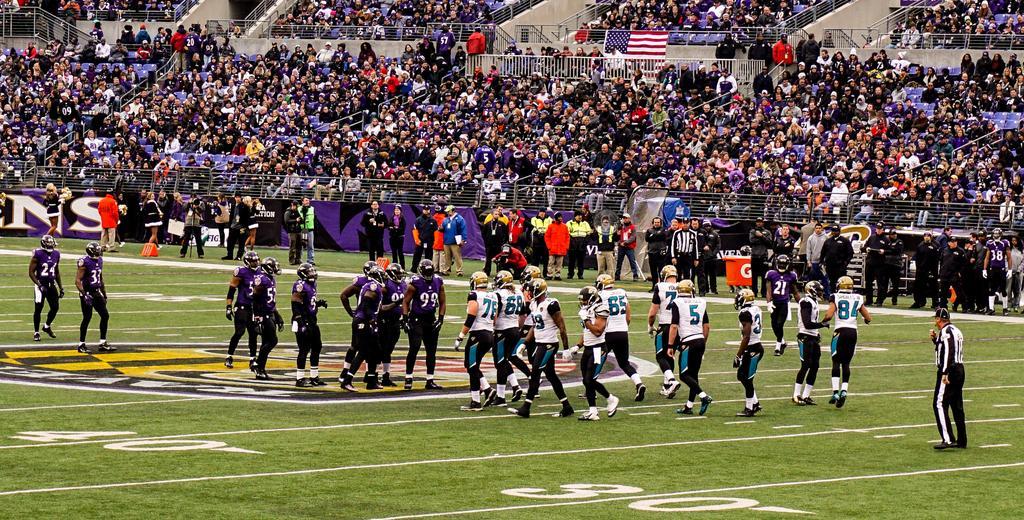Please provide a concise description of this image. In this image there is a ground, in that ground there are players, in the background there are people are sitting on chairs and few people are standing. 